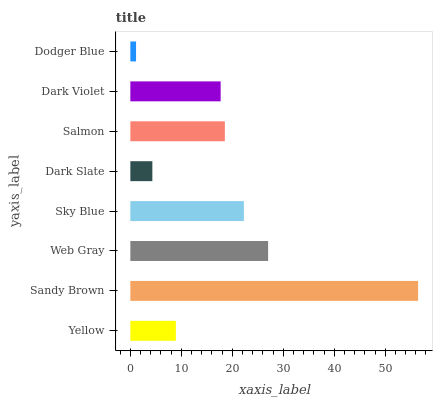Is Dodger Blue the minimum?
Answer yes or no. Yes. Is Sandy Brown the maximum?
Answer yes or no. Yes. Is Web Gray the minimum?
Answer yes or no. No. Is Web Gray the maximum?
Answer yes or no. No. Is Sandy Brown greater than Web Gray?
Answer yes or no. Yes. Is Web Gray less than Sandy Brown?
Answer yes or no. Yes. Is Web Gray greater than Sandy Brown?
Answer yes or no. No. Is Sandy Brown less than Web Gray?
Answer yes or no. No. Is Salmon the high median?
Answer yes or no. Yes. Is Dark Violet the low median?
Answer yes or no. Yes. Is Web Gray the high median?
Answer yes or no. No. Is Yellow the low median?
Answer yes or no. No. 